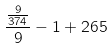<formula> <loc_0><loc_0><loc_500><loc_500>\frac { \frac { 9 } { 3 7 4 } } { 9 } - 1 + 2 6 5</formula> 